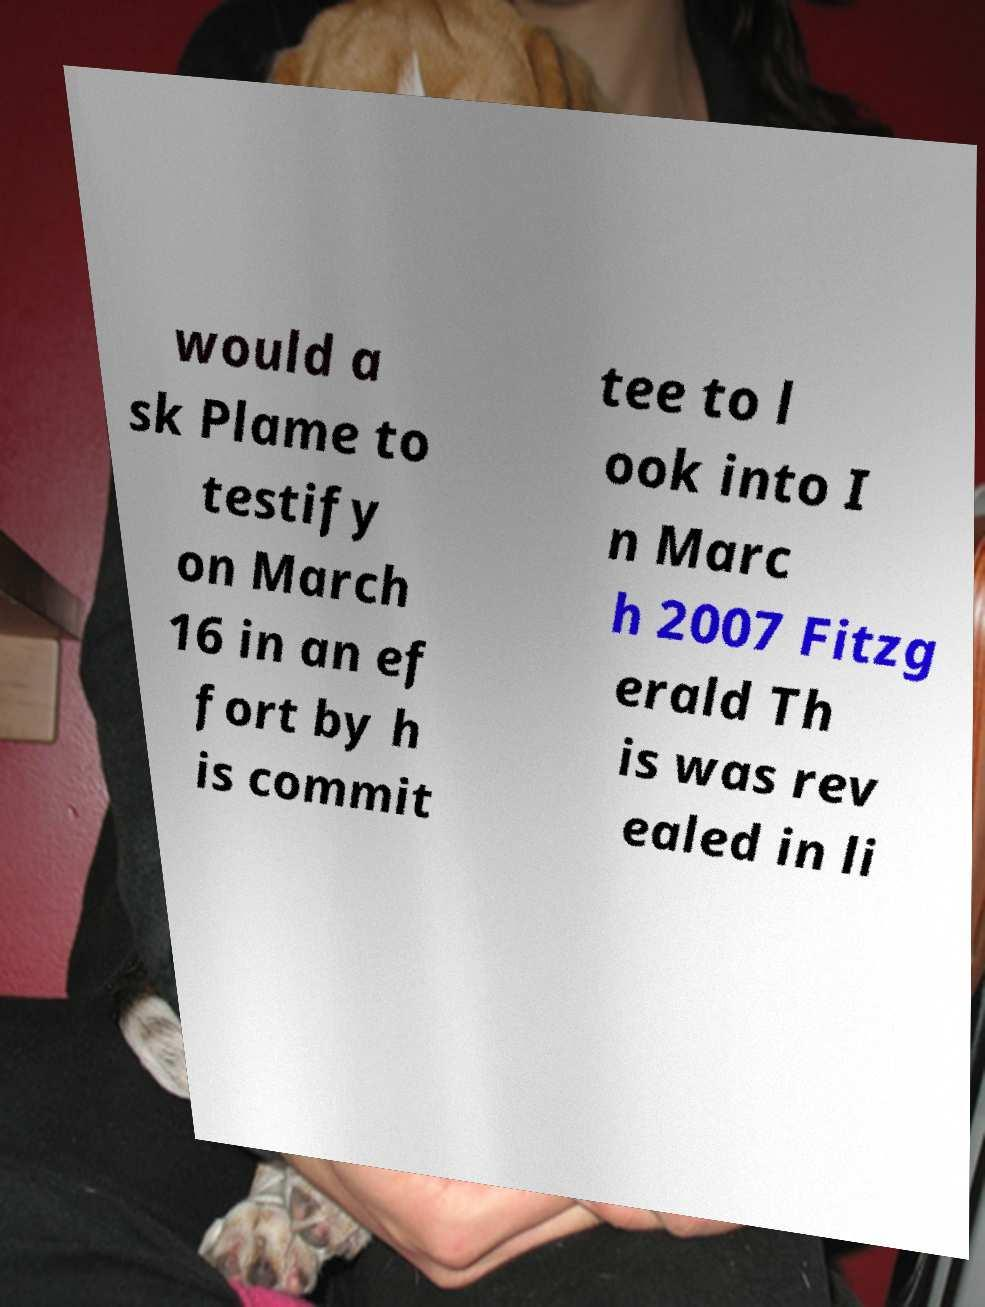Please read and relay the text visible in this image. What does it say? would a sk Plame to testify on March 16 in an ef fort by h is commit tee to l ook into I n Marc h 2007 Fitzg erald Th is was rev ealed in li 